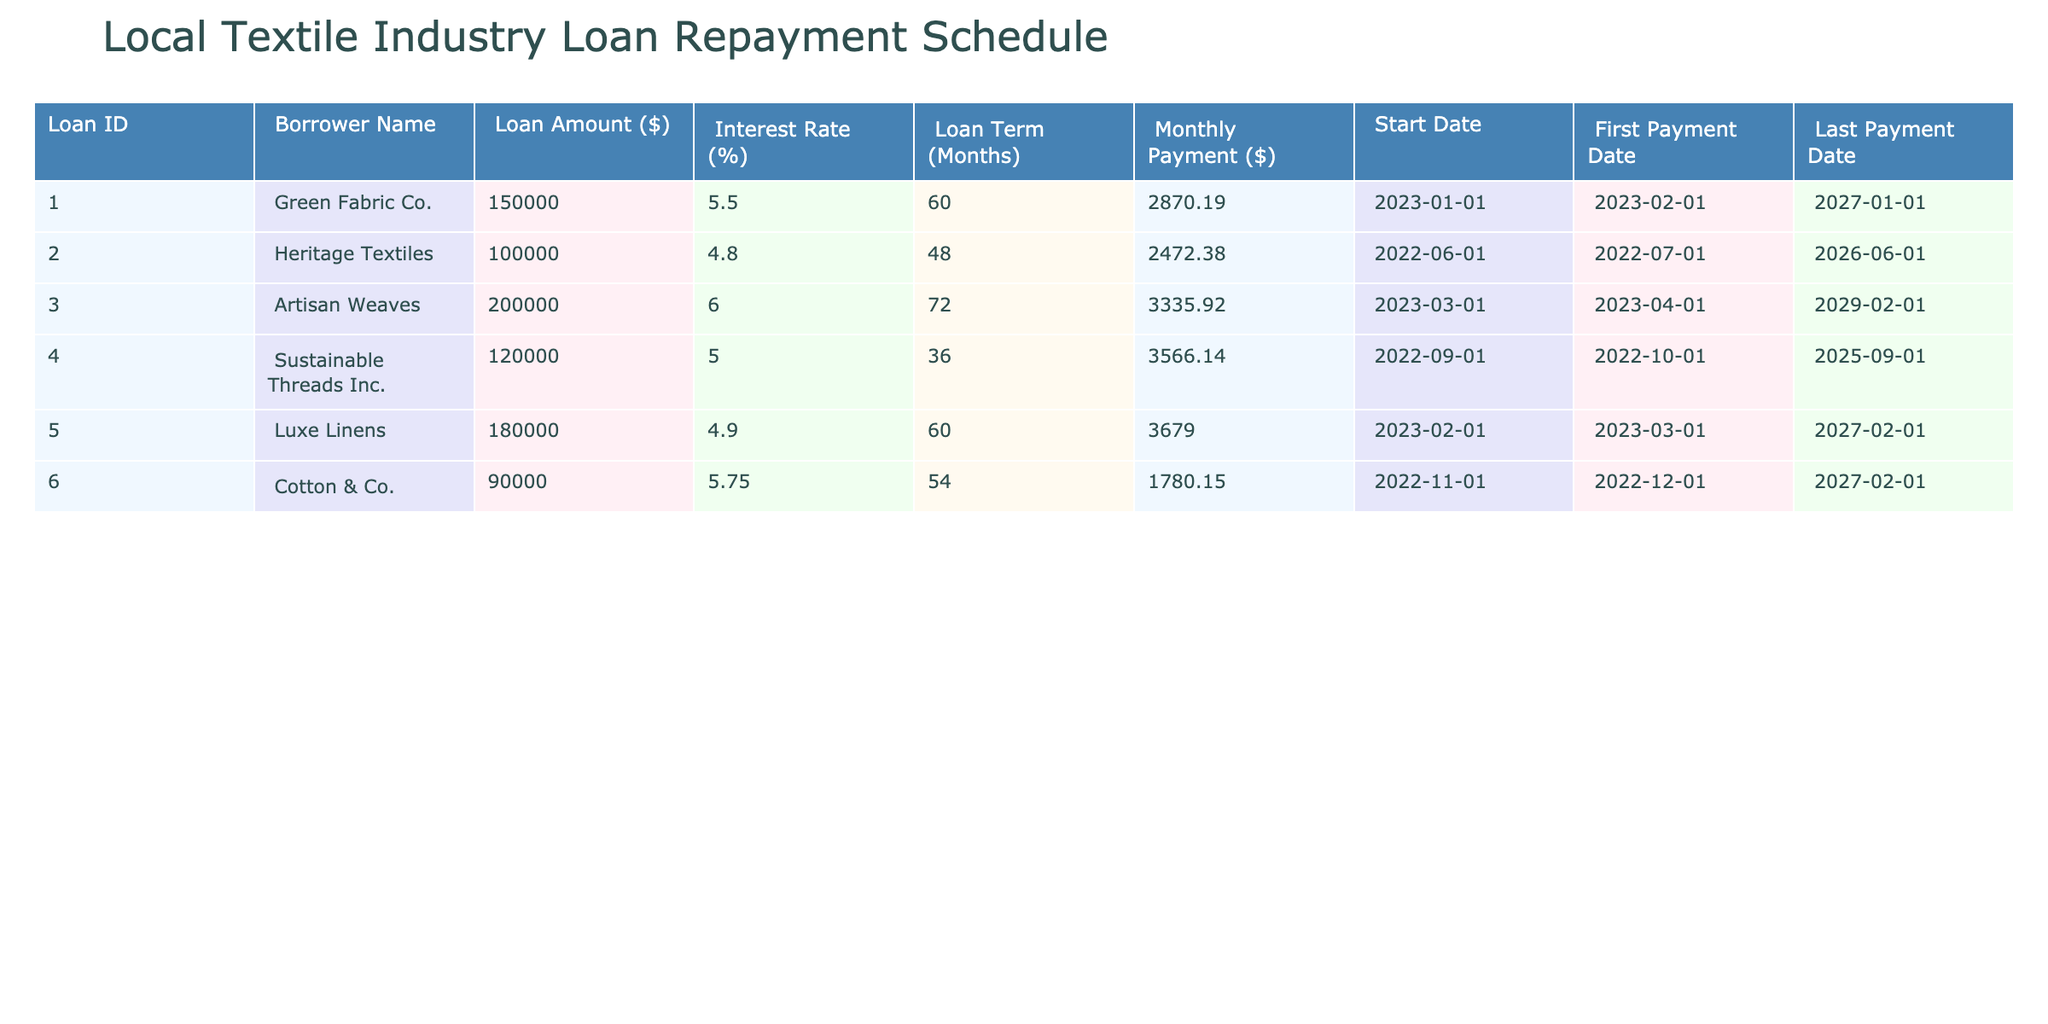What is the loan amount for Heritage Textiles? The loan amount is listed in the corresponding row for Heritage Textiles under the "Loan Amount ($)" column. The amount is $100,000.
Answer: $100,000 How many months is the loan term for Luxe Linens? The loan term is clearly stated in the "Loan Term (Months)" column for Luxe Linens. It shows 60 months.
Answer: 60 months Which borrower has the lowest monthly payment and what is the amount? The monthly payment can be found in the "Monthly Payment ($)" column. By scanning through this column, we see that Cotton & Co. has the lowest payment of $1,780.15.
Answer: $1,780.15 Is Sustainable Threads Inc. paying more monthly than Artisan Weaves? To answer this, we compare the amounts in the "Monthly Payment ($)" column for both borrowers. Sustainable Threads Inc. pays $3,566.14 while Artisan Weaves pays $3,335.92. Since $3,566.14 is greater, the answer is yes.
Answer: Yes What is the total loan amount for the first three borrowers? To find the total, we sum the "Loan Amount ($)" values for the first three borrowers: Green Fabric Co. ($150,000) + Heritage Textiles ($100,000) + Artisan Weaves ($200,000) = $450,000.
Answer: $450,000 How many borrowers have a loan term greater than 60 months? We can count the "Loan Term (Months)" values that exceed 60. Artisan Weaves is the only borrower with 72 months, while others have lesser durations. Hence, there is only one borrower.
Answer: 1 What is the interest rate of Cotton & Co.? The interest rate for Cotton & Co. is located under the "Interest Rate (%)" column. It shows a rate of 5.75%.
Answer: 5.75% Which two borrowers have a loan term of 60 months? We look at the "Loan Term (Months)" column and find that Green Fabric Co. and Luxe Linens both have a term of 60 months.
Answer: Green Fabric Co. and Luxe Linens 